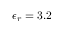Convert formula to latex. <formula><loc_0><loc_0><loc_500><loc_500>\epsilon _ { r } = 3 . 2</formula> 